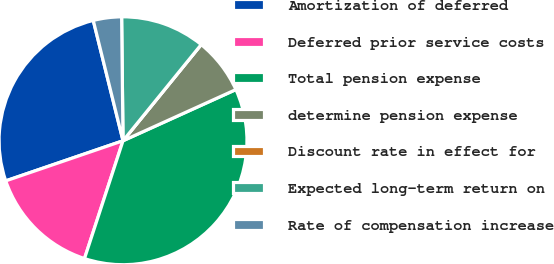Convert chart. <chart><loc_0><loc_0><loc_500><loc_500><pie_chart><fcel>Amortization of deferred<fcel>Deferred prior service costs<fcel>Total pension expense<fcel>determine pension expense<fcel>Discount rate in effect for<fcel>Expected long-term return on<fcel>Rate of compensation increase<nl><fcel>26.38%<fcel>14.72%<fcel>36.8%<fcel>7.36%<fcel>0.0%<fcel>11.04%<fcel>3.68%<nl></chart> 